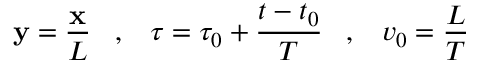Convert formula to latex. <formula><loc_0><loc_0><loc_500><loc_500>{ \mathbf y } = \frac { \mathbf x } { L } \, , \, \tau = \tau _ { 0 } + \frac { t - t _ { 0 } } { T } \, , \, v _ { 0 } = \frac { L } { T }</formula> 